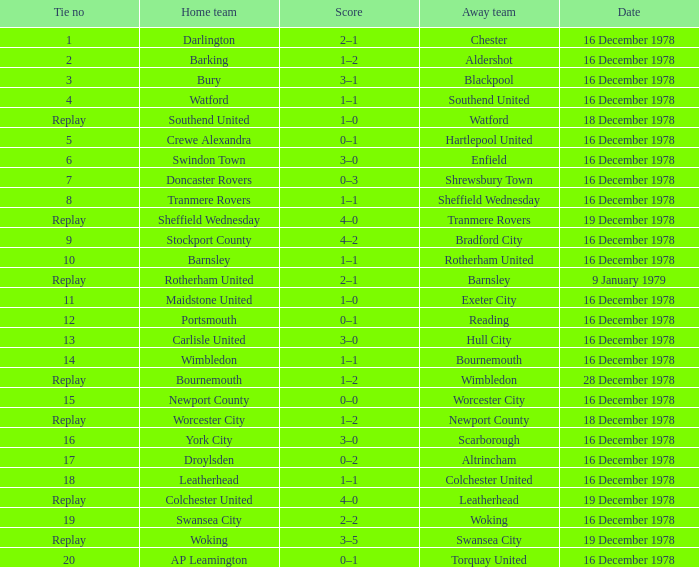What date had a tie no of replay, and an away team of watford? 18 December 1978. 